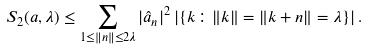Convert formula to latex. <formula><loc_0><loc_0><loc_500><loc_500>S _ { 2 } ( a , \lambda ) \leq \sum _ { 1 \leq \| n \| \leq 2 \lambda } | \hat { a } _ { n } | ^ { 2 } \left | \left \{ k \colon \| k \| = \| k + n \| = \lambda \right \} \right | .</formula> 